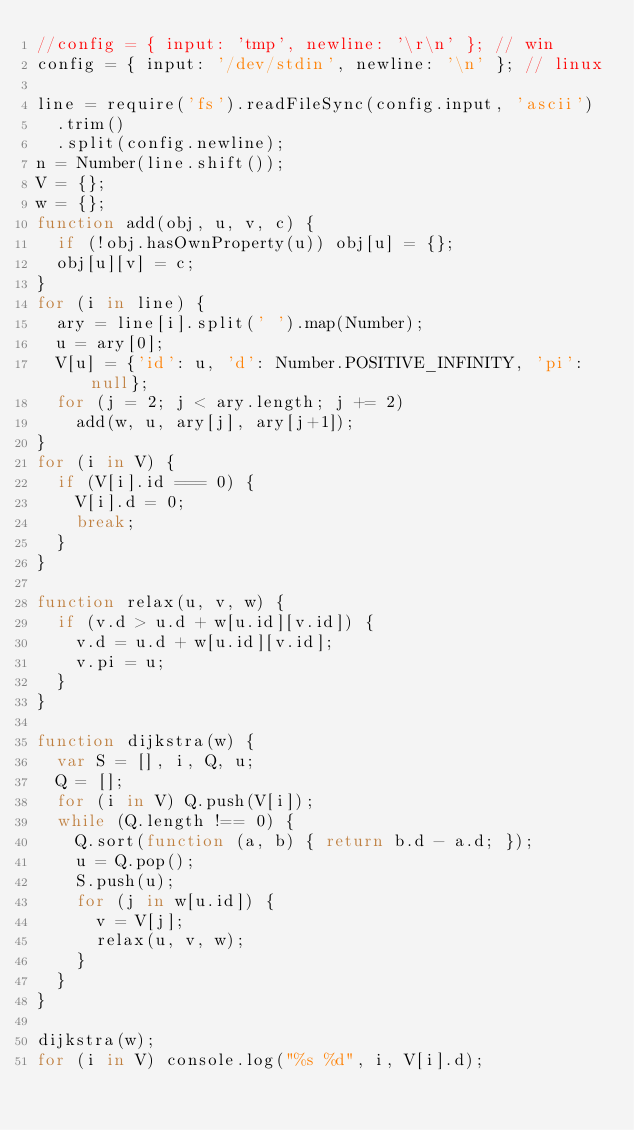<code> <loc_0><loc_0><loc_500><loc_500><_JavaScript_>//config = { input: 'tmp', newline: '\r\n' }; // win
config = { input: '/dev/stdin', newline: '\n' }; // linux

line = require('fs').readFileSync(config.input, 'ascii')
  .trim()
  .split(config.newline);
n = Number(line.shift());
V = {};
w = {};
function add(obj, u, v, c) {
  if (!obj.hasOwnProperty(u)) obj[u] = {};
  obj[u][v] = c;
}
for (i in line) {
  ary = line[i].split(' ').map(Number);
  u = ary[0];
  V[u] = {'id': u, 'd': Number.POSITIVE_INFINITY, 'pi': null};
  for (j = 2; j < ary.length; j += 2)
    add(w, u, ary[j], ary[j+1]);
}
for (i in V) {
  if (V[i].id === 0) {
    V[i].d = 0;
    break;
  }
}

function relax(u, v, w) {
  if (v.d > u.d + w[u.id][v.id]) {
    v.d = u.d + w[u.id][v.id];
    v.pi = u;
  }
}

function dijkstra(w) {
  var S = [], i, Q, u;
  Q = [];
  for (i in V) Q.push(V[i]);
  while (Q.length !== 0) {
    Q.sort(function (a, b) { return b.d - a.d; });
    u = Q.pop();
    S.push(u);
    for (j in w[u.id]) {
      v = V[j];
      relax(u, v, w);
    }
  }
}

dijkstra(w);
for (i in V) console.log("%s %d", i, V[i].d);</code> 